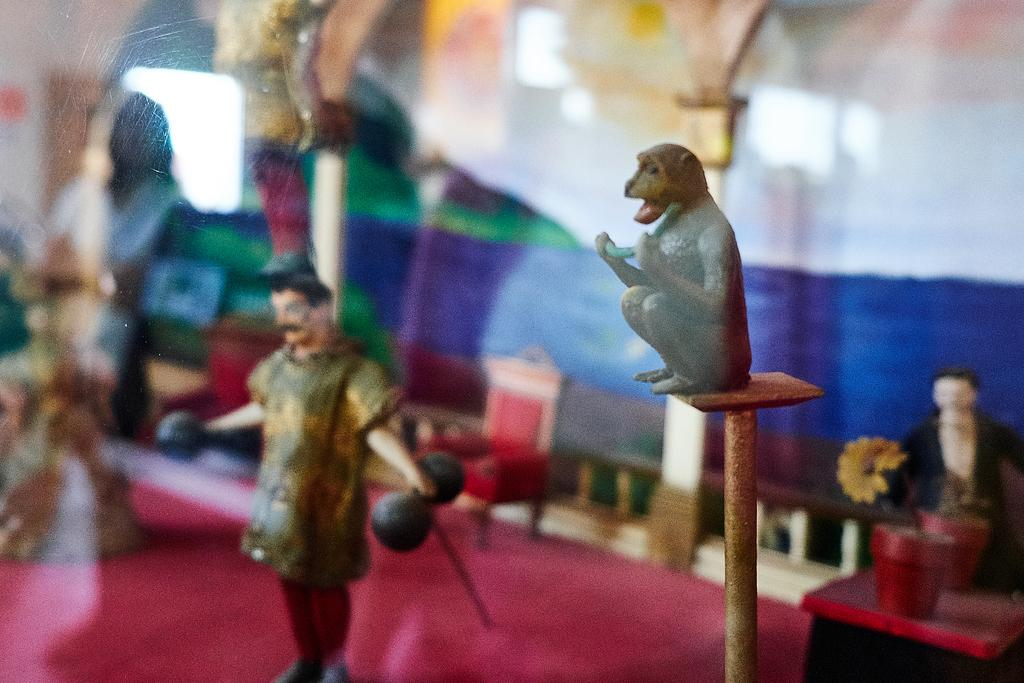What types of toys are present in the image? There are a monkey toy, a person toy, and a chair toy in the image. What other object can be seen in the image besides toys? There are flower pots in the image. Are there any flower-related toys in the image? Yes, there is a flower toy in the image. What type of door can be seen in the image? The image appears to show a glass door. Can you see a stream of water flowing near the toys in the image? There is no stream of water visible in the image. What idea does the flower toy represent in the image? The image does not convey any specific ideas or concepts; it simply shows toys and flower pots. 